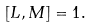Convert formula to latex. <formula><loc_0><loc_0><loc_500><loc_500>\left [ L , M \right ] = 1 .</formula> 